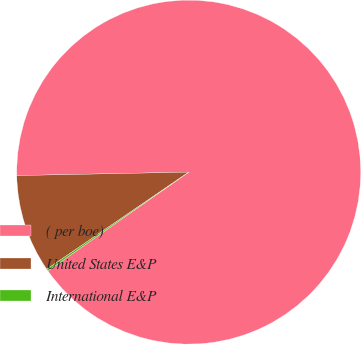Convert chart to OTSL. <chart><loc_0><loc_0><loc_500><loc_500><pie_chart><fcel>( per boe)<fcel>United States E&P<fcel>International E&P<nl><fcel>90.57%<fcel>9.23%<fcel>0.19%<nl></chart> 